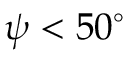<formula> <loc_0><loc_0><loc_500><loc_500>\psi < 5 0 ^ { \circ }</formula> 